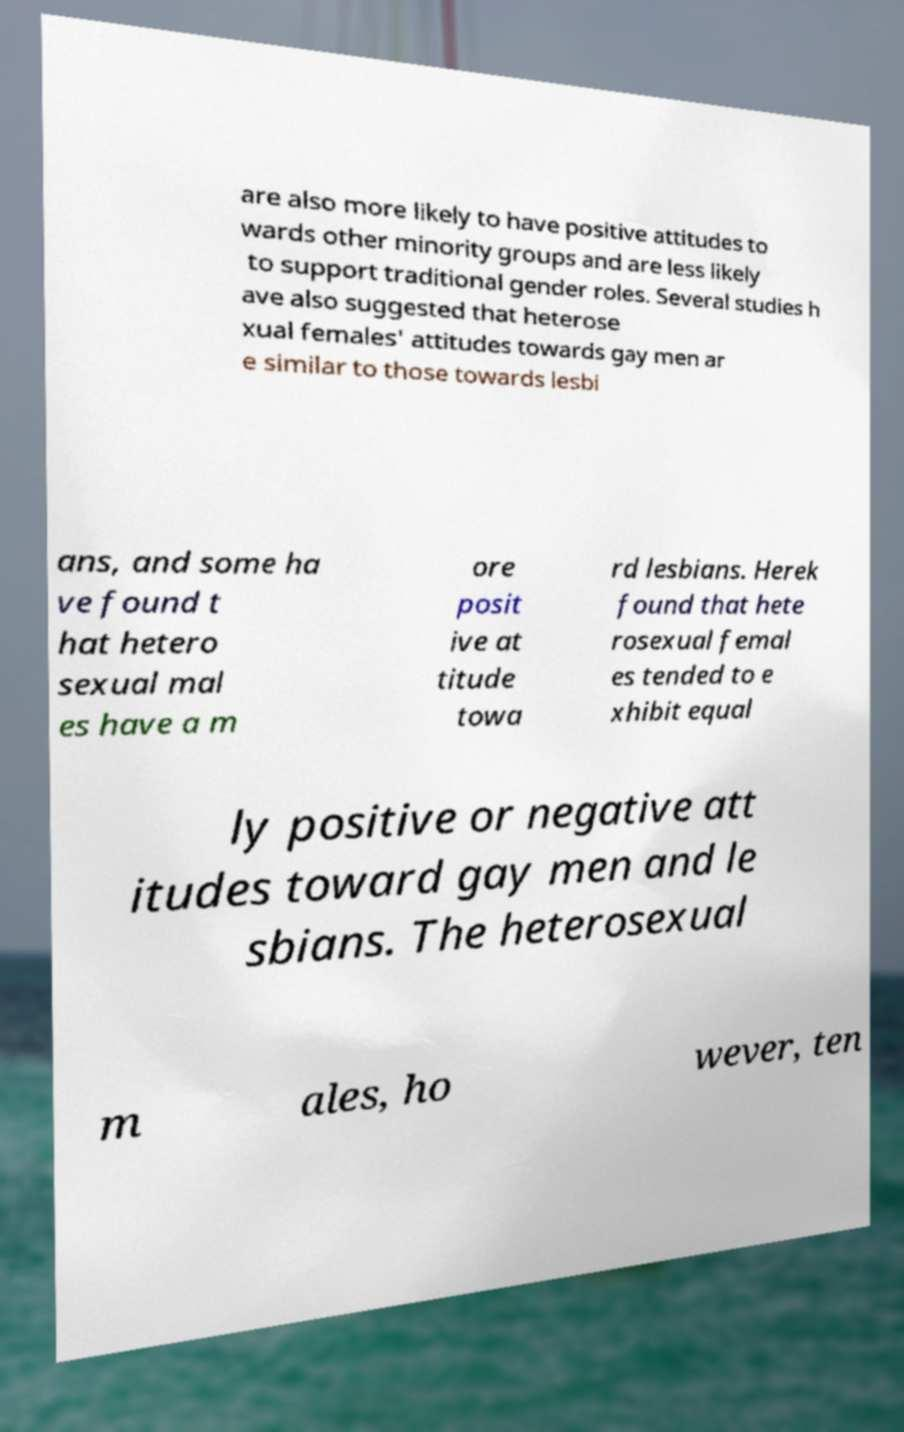Please identify and transcribe the text found in this image. are also more likely to have positive attitudes to wards other minority groups and are less likely to support traditional gender roles. Several studies h ave also suggested that heterose xual females' attitudes towards gay men ar e similar to those towards lesbi ans, and some ha ve found t hat hetero sexual mal es have a m ore posit ive at titude towa rd lesbians. Herek found that hete rosexual femal es tended to e xhibit equal ly positive or negative att itudes toward gay men and le sbians. The heterosexual m ales, ho wever, ten 